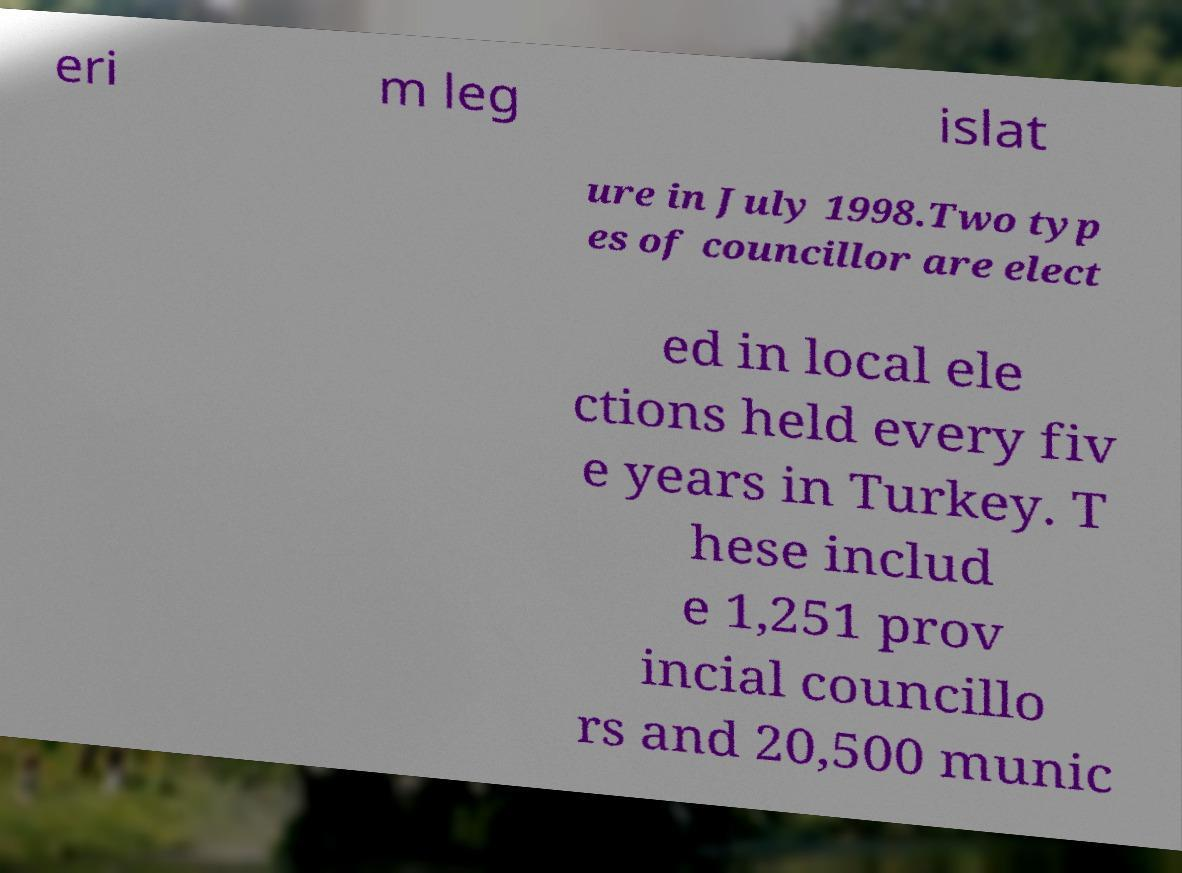Please read and relay the text visible in this image. What does it say? eri m leg islat ure in July 1998.Two typ es of councillor are elect ed in local ele ctions held every fiv e years in Turkey. T hese includ e 1,251 prov incial councillo rs and 20,500 munic 